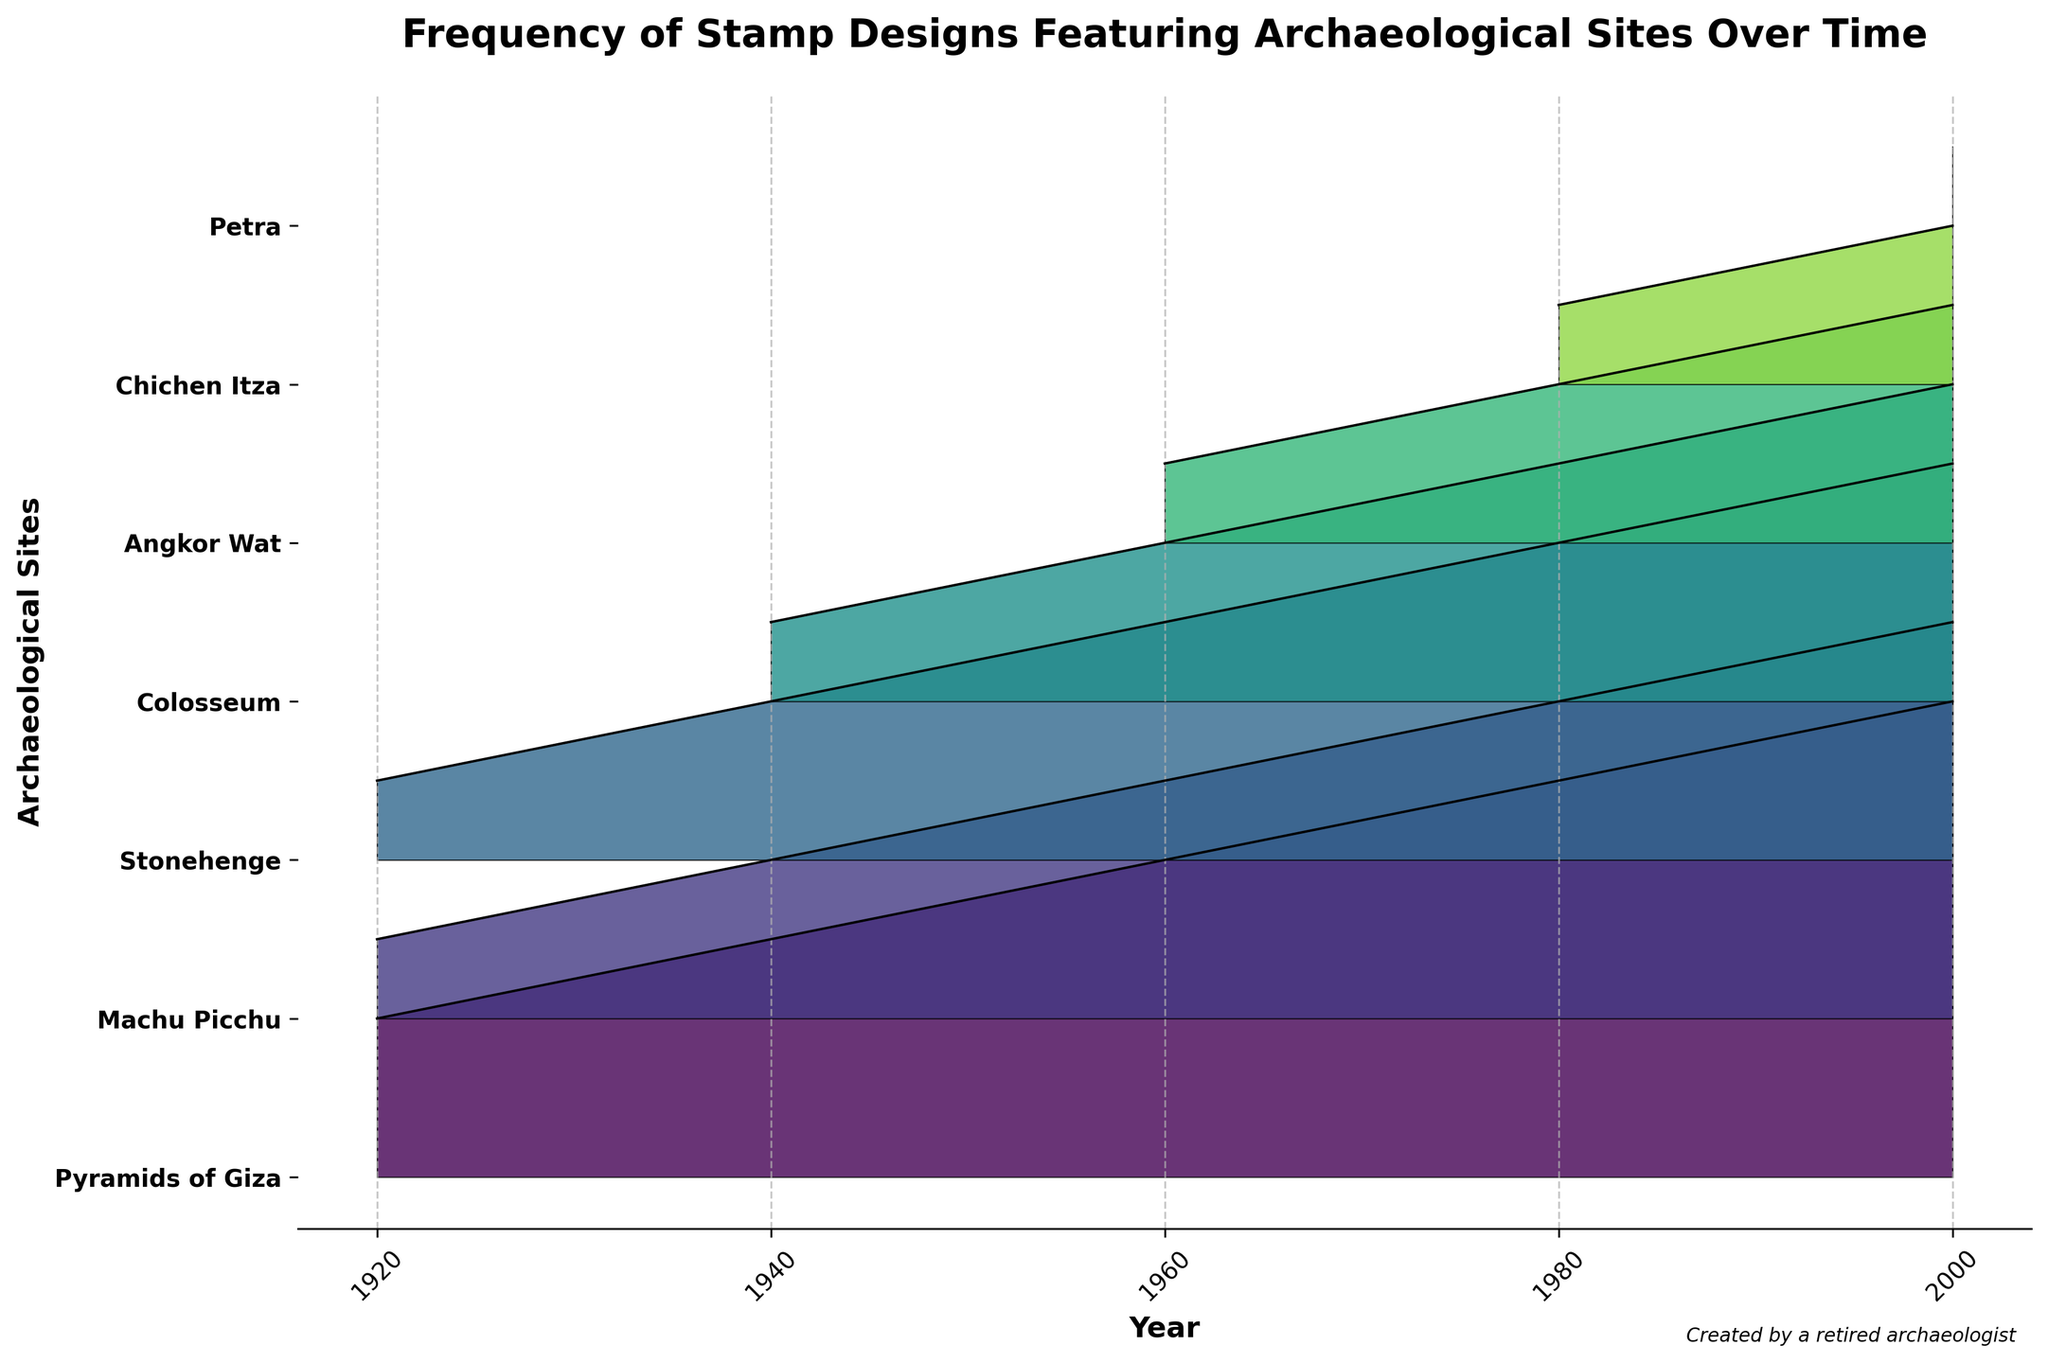Which archaeological site has the highest frequency of stamp designs in 2000? Look at the bar heights corresponding to each site in 2000. The Pyramids of Giza have the highest bar, indicating they have the highest frequency.
Answer: Pyramids of Giza What is the general trend of the frequency of stamp designs featuring the Pyramids of Giza? Observe the fill areas for the Pyramids of Giza from 1920 to 2000. The frequency consistently increases every decade.
Answer: Consistently increasing Which two archaeological sites first appeared on stamps in 1980? Check which sites have fill areas that start at 1980. Angkor Wat and Chichen Itza first appear in 1980.
Answer: Angkor Wat and Chichen Itza How many archaeological sites show an increasing trend in frequency from 1920 to 2000? Each site is checked from its starting point to its ending point. All sites show an increasing trend: Pyramids of Giza, Machu Picchu, Stonehenge, Colosseum, Angkor Wat, Chichen Itza, and Petra.
Answer: Seven sites Which year features Petra in stamp designs for the first time? Examine the areas corresponding to Petra. It first appears in 2000.
Answer: 2000 Which site had the second highest frequency in 1940? Look at the heights of the fill areas for 1940. Machu Picchu and Stonehenge both have the second highest frequency of 2.
Answer: Machu Picchu and Stonehenge Which site's frequency grew the fastest between 1940 and 1960? Measure the change in bar heights from 1940 to 1960. The Pyramids of Giza's frequency increases from 3 to 4, i.e., by 1, Machu Picchu and Stonehenge increase from 2 to 3, i.e., by 1. Colosseum increases from 1 to 2, i.e., by 1. So, all sites grew at the same rate except for Angkor Wat, which wasn't present in 1940.
Answer: All grew equally (ratio 1) What is the combined frequency of all archaeological sites in 1980? Add up the frequencies for each site in 1980: 5 (Pyramids of Giza) + 4 (Machu Picchu) + 4 (Stonehenge) + 3 (Colosseum) + 2 (Angkor Wat) + 1 (Chichen Itza). Total frequency is 19.
Answer: 19 Which two sites had a frequency of 3 in 2000? Check the fill areas for 2000 for the frequency of 3. Colosseum and Angkor Wat both show a frequency of 3.
Answer: Colosseum and Angkor Wat 